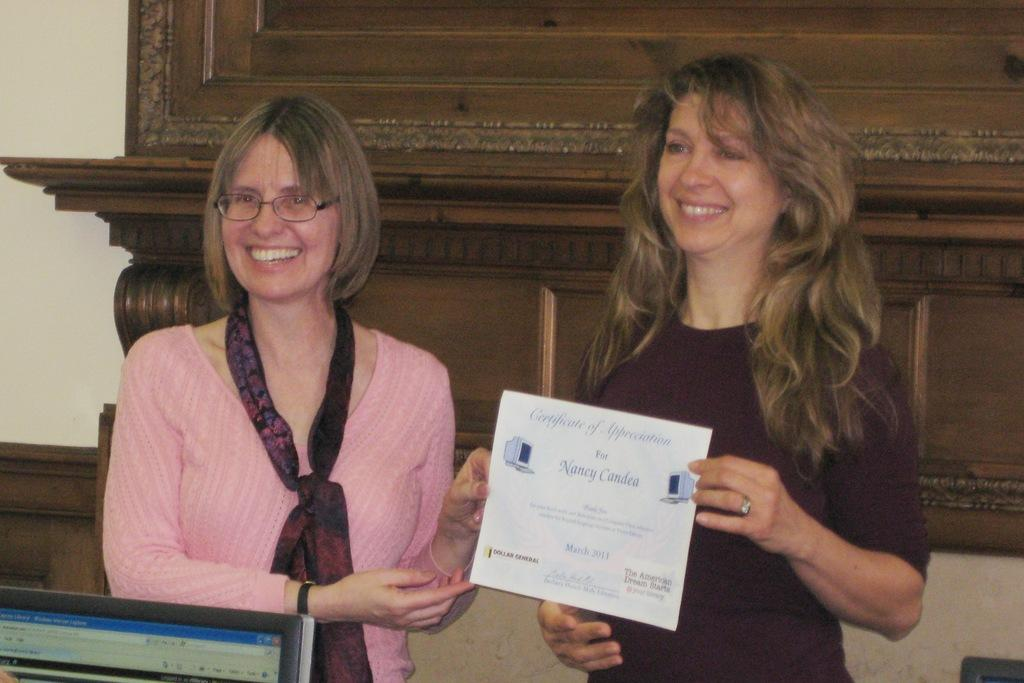<image>
Share a concise interpretation of the image provided. nancy Candea is being recognized with a certificate of appreciation 